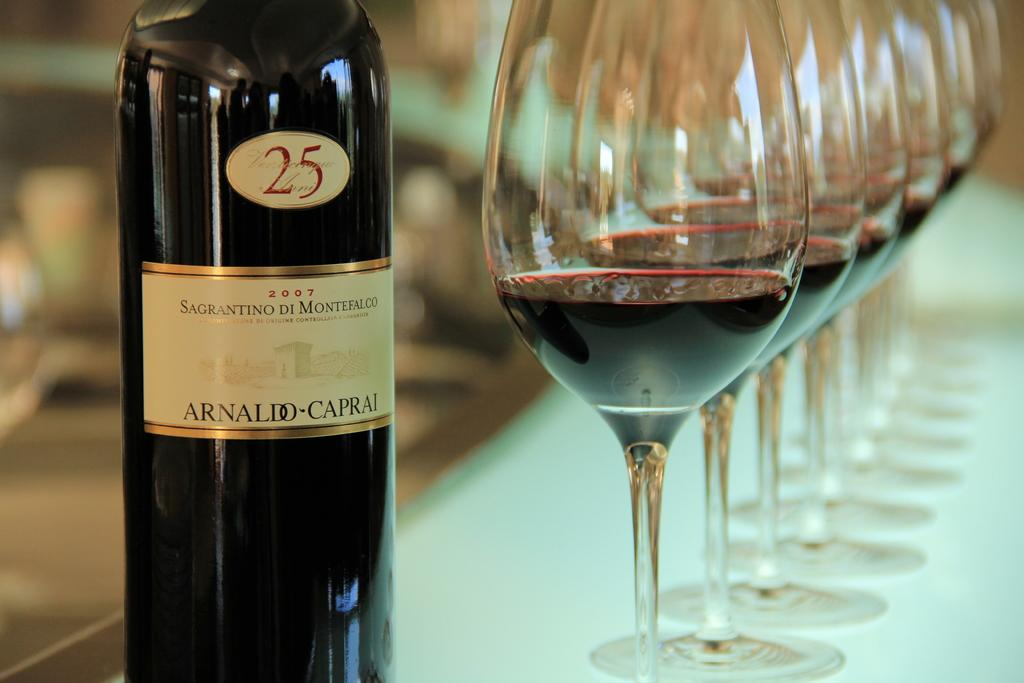Provide a one-sentence caption for the provided image. A bottle of Arnaldo Caprai wine is next to several glasses of wine. 